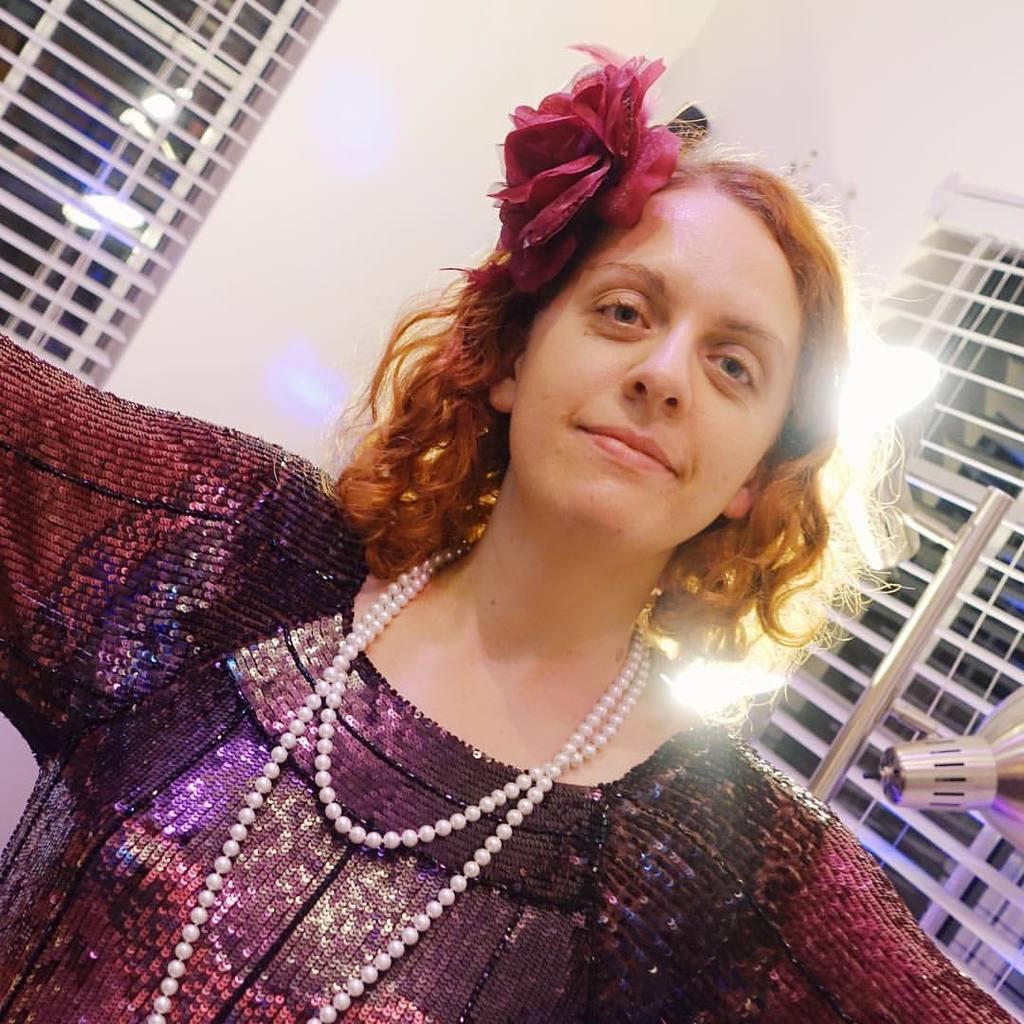In one or two sentences, can you explain what this image depicts? In this image we can see a woman wearing dress, pearls chain and head wear is standing here and smiling. In the background, we can see the lights and windows. 